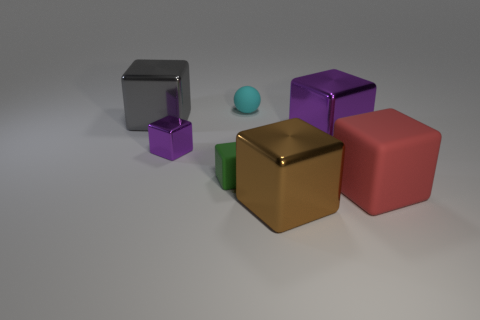Is there any other thing that has the same shape as the tiny cyan matte object?
Ensure brevity in your answer.  No. Is the shape of the large gray thing the same as the tiny matte thing that is behind the large gray metal thing?
Give a very brief answer. No. What is the size of the other purple shiny thing that is the same shape as the big purple shiny object?
Your answer should be very brief. Small. There is a matte block to the left of the cyan rubber thing; is it the same size as the cyan matte thing?
Give a very brief answer. Yes. What size is the object that is both to the left of the big red thing and on the right side of the large brown metal cube?
Make the answer very short. Large. How many metal objects have the same color as the tiny metal cube?
Your response must be concise. 1. Are there the same number of brown metallic blocks to the left of the big gray shiny block and small purple matte cubes?
Your answer should be compact. Yes. The tiny rubber ball has what color?
Your answer should be very brief. Cyan. The sphere that is made of the same material as the green block is what size?
Make the answer very short. Small. The ball that is the same material as the tiny green cube is what color?
Your answer should be very brief. Cyan. 